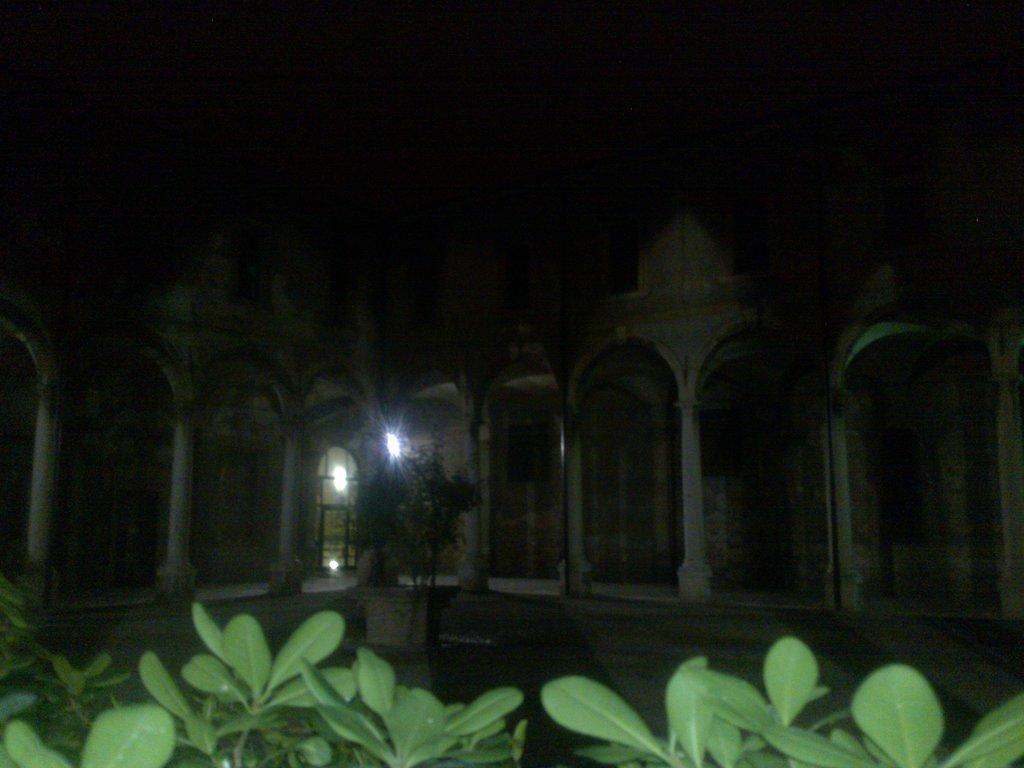What type of vegetation is present at the bottom of the image? There are plants at the bottom side of the image. What structure is located in the center of the image? There is a building in the center of the image. How many geese are seen walking around the plants in the image? There are no geese present in the image; it only features plants and a building. What type of cactus is located next to the sister in the image? There is no cactus or sister present in the image. 